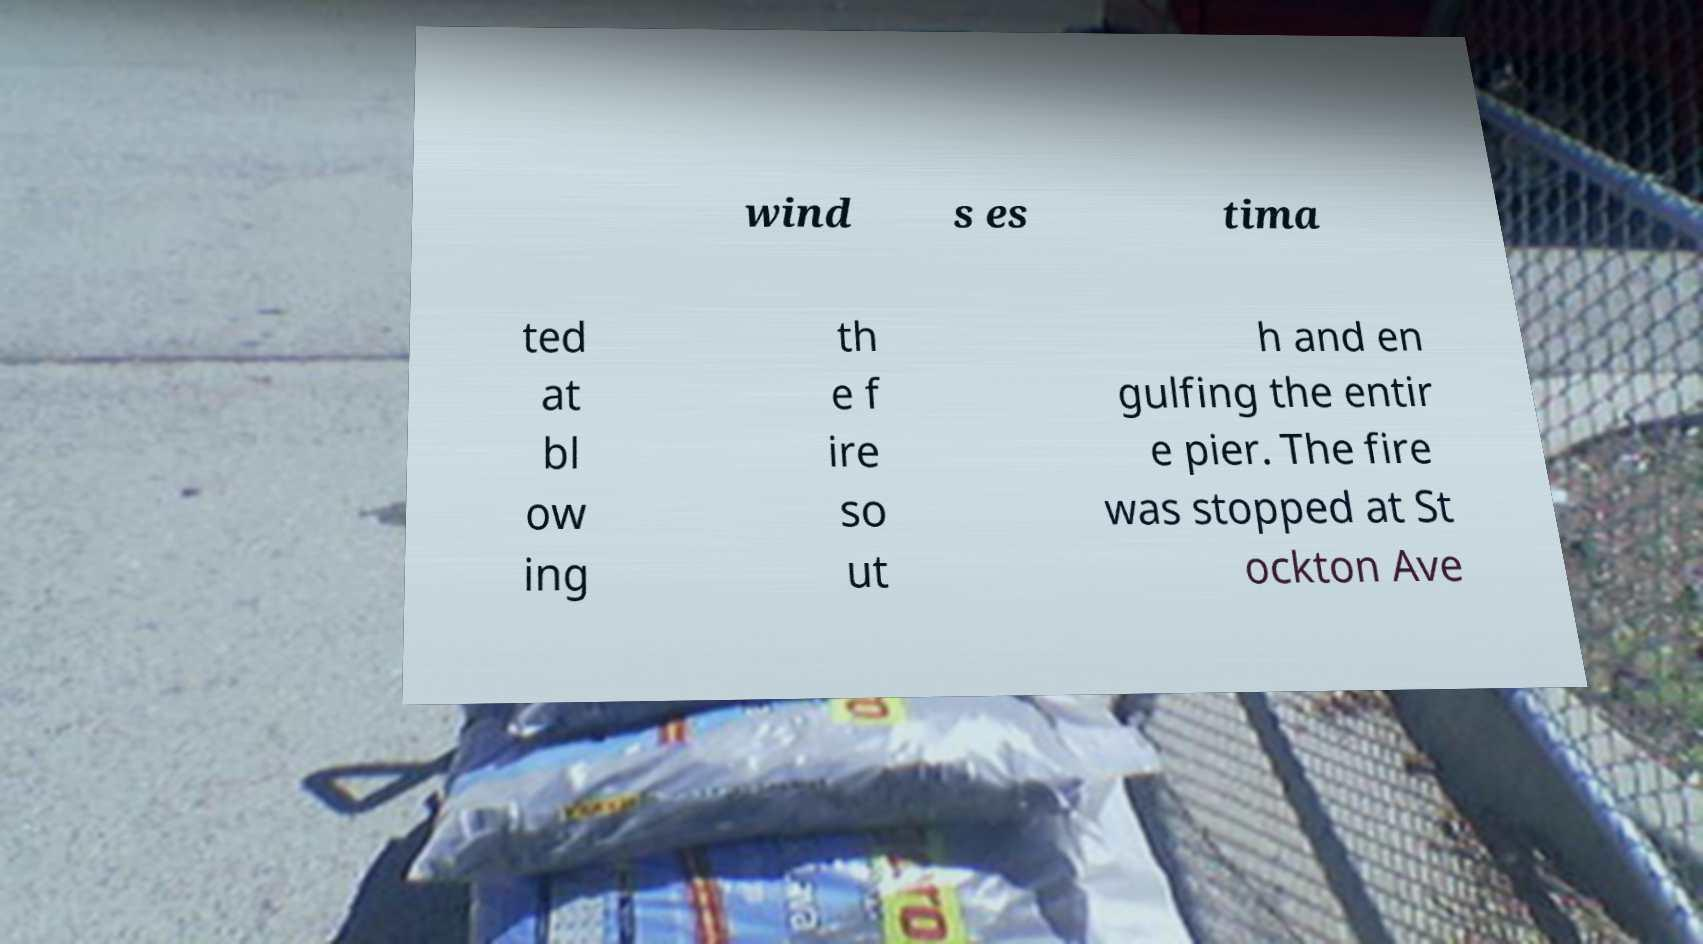Could you extract and type out the text from this image? wind s es tima ted at bl ow ing th e f ire so ut h and en gulfing the entir e pier. The fire was stopped at St ockton Ave 